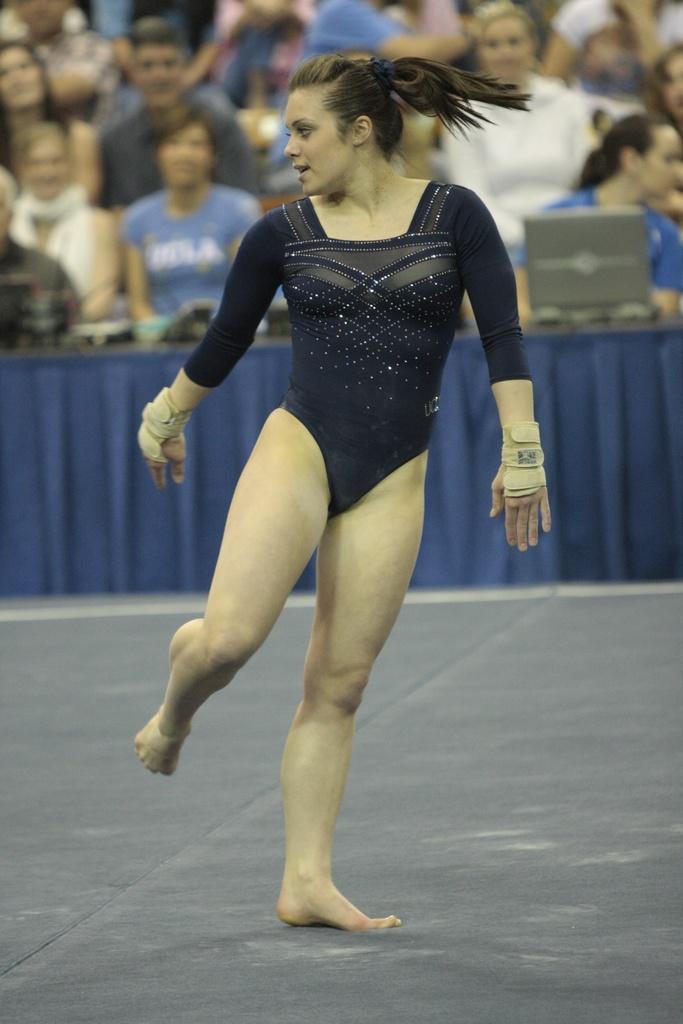Could you give a brief overview of what you see in this image? In this picture there is a girl in the center of the image and there are other people those who are sitting in front of a table in the background of the image, there is a laptop on the table. 